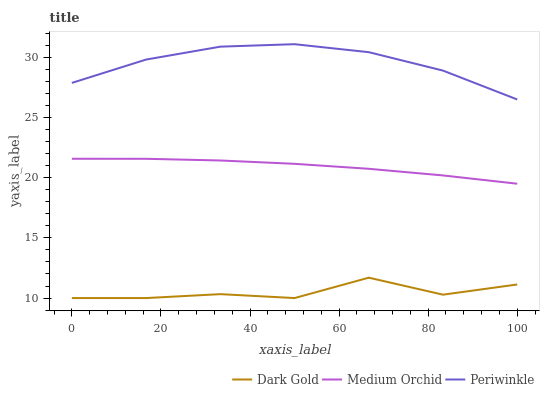Does Dark Gold have the minimum area under the curve?
Answer yes or no. Yes. Does Periwinkle have the maximum area under the curve?
Answer yes or no. Yes. Does Periwinkle have the minimum area under the curve?
Answer yes or no. No. Does Dark Gold have the maximum area under the curve?
Answer yes or no. No. Is Medium Orchid the smoothest?
Answer yes or no. Yes. Is Dark Gold the roughest?
Answer yes or no. Yes. Is Periwinkle the smoothest?
Answer yes or no. No. Is Periwinkle the roughest?
Answer yes or no. No. Does Dark Gold have the lowest value?
Answer yes or no. Yes. Does Periwinkle have the lowest value?
Answer yes or no. No. Does Periwinkle have the highest value?
Answer yes or no. Yes. Does Dark Gold have the highest value?
Answer yes or no. No. Is Dark Gold less than Medium Orchid?
Answer yes or no. Yes. Is Medium Orchid greater than Dark Gold?
Answer yes or no. Yes. Does Dark Gold intersect Medium Orchid?
Answer yes or no. No. 